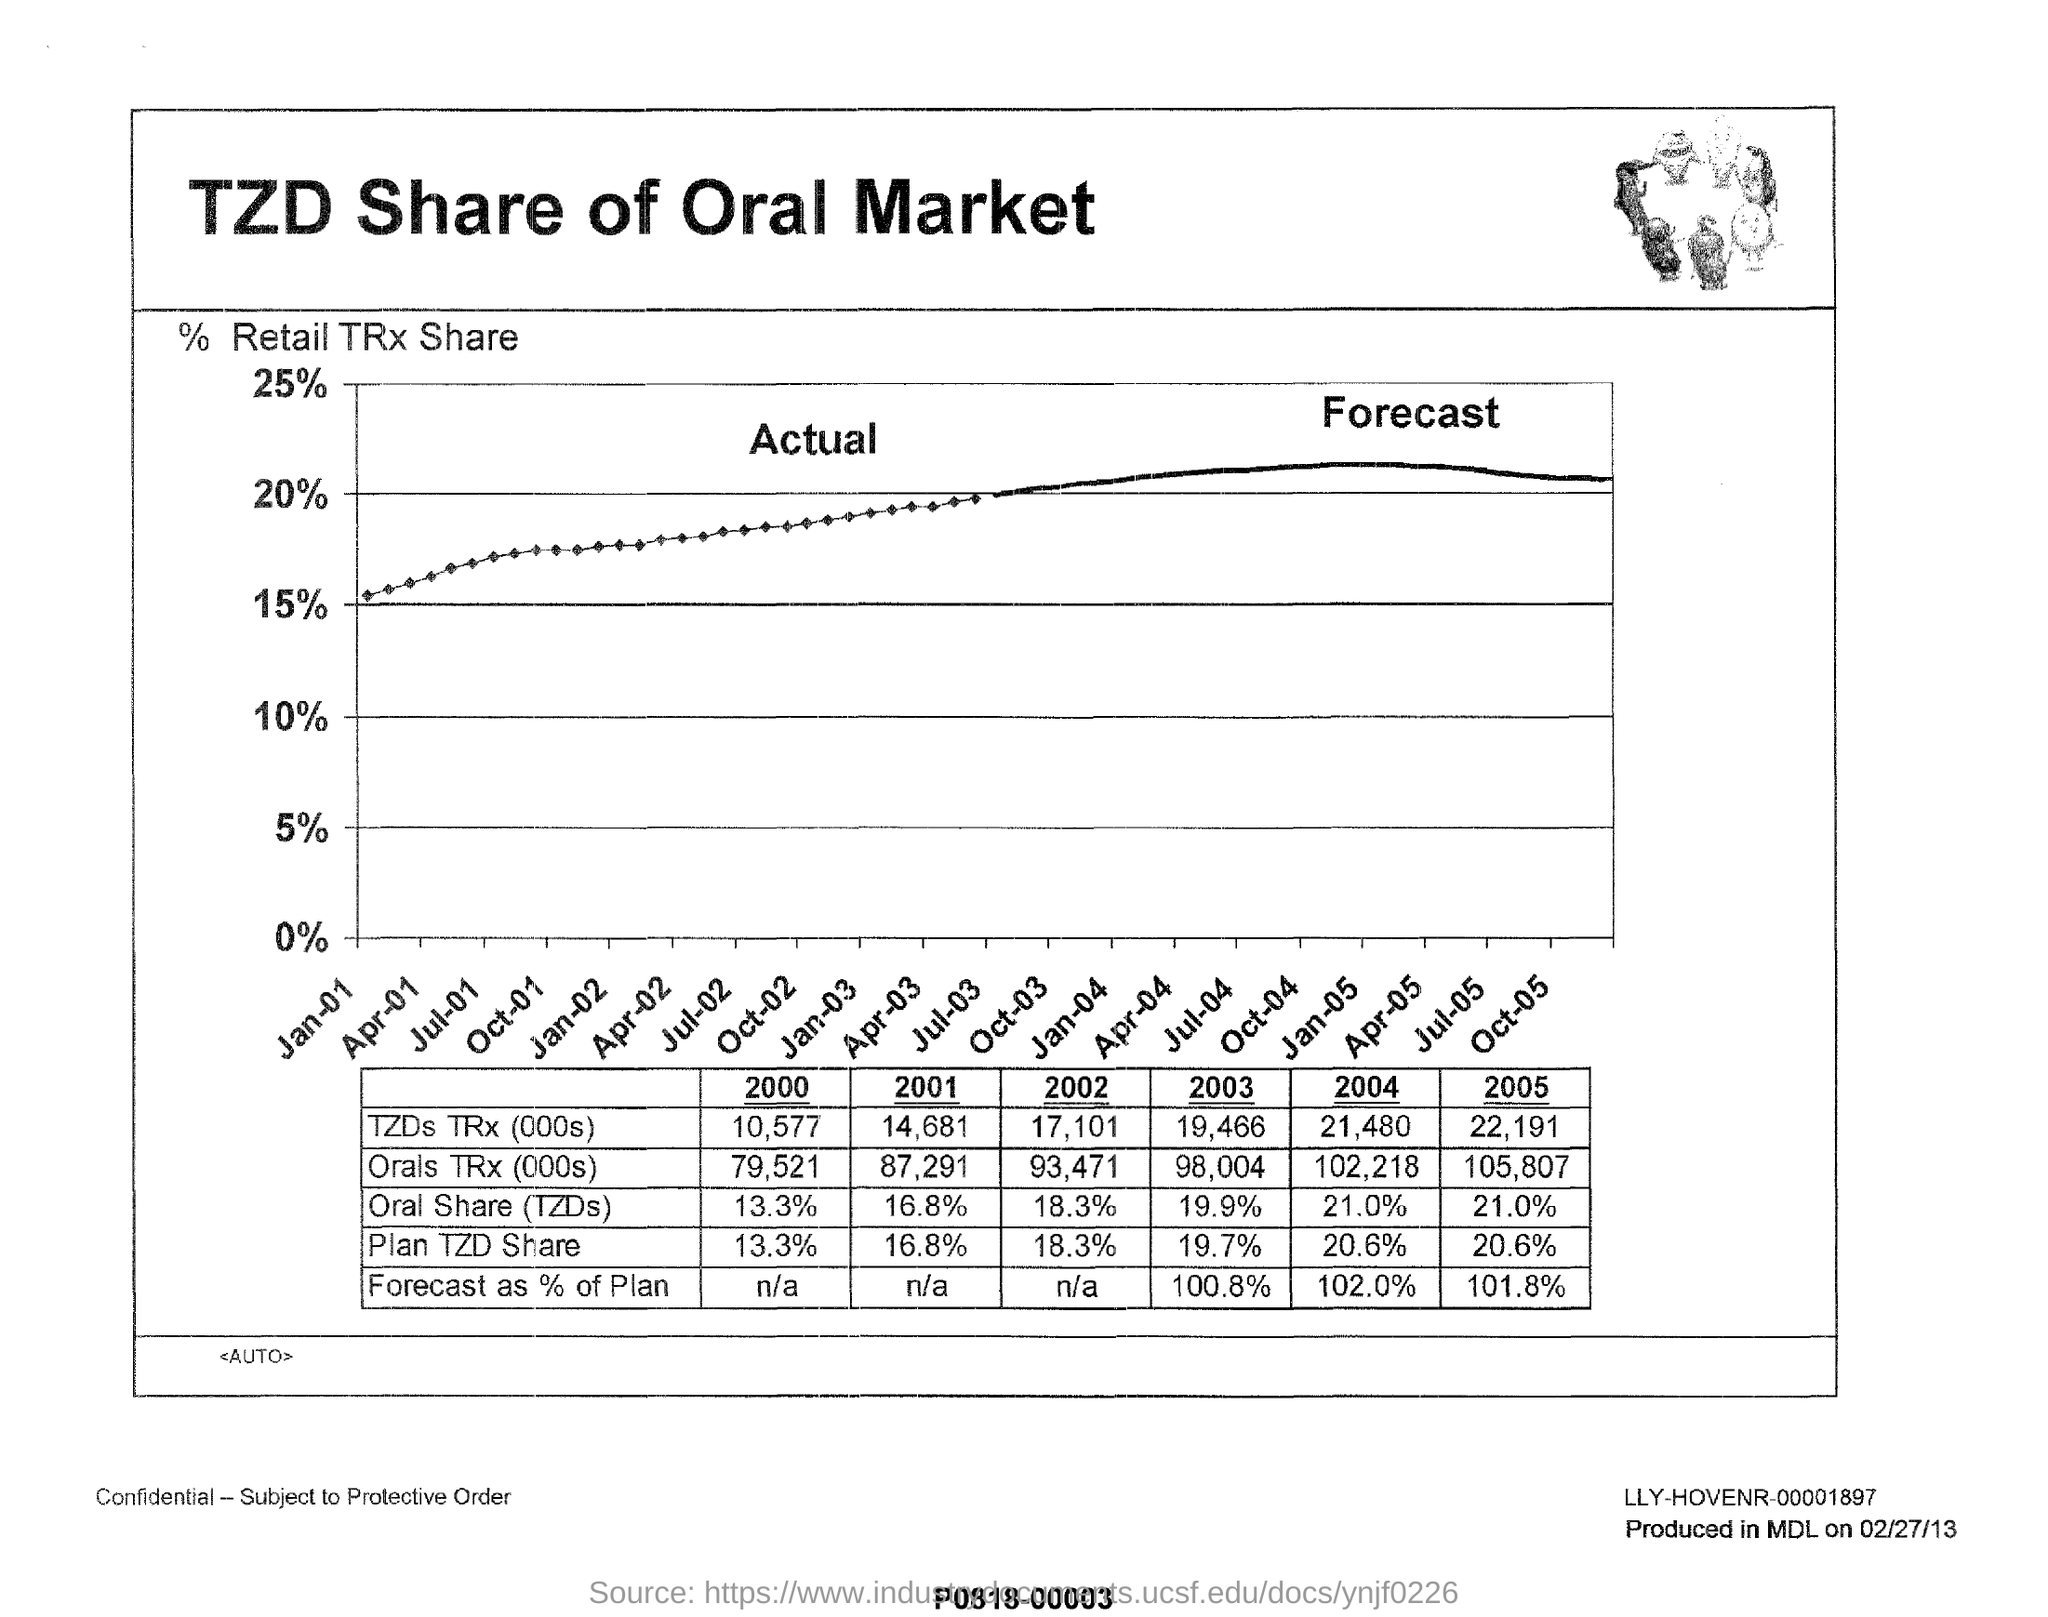What does the graph describes in this document?
Your answer should be compact. TZD Share of Oral Market. What is the Plan TZD Share for the year 2003?
Offer a terse response. 19.7%. Which year has 13.3% Oral share (TZD)?
Offer a very short reply. 2000. 